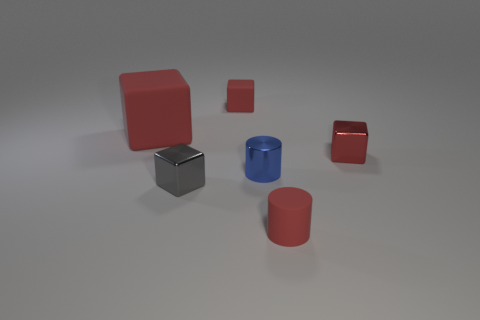How many other things are the same color as the big matte cube?
Give a very brief answer. 3. There is a metallic block behind the gray thing; does it have the same size as the blue metallic cylinder?
Ensure brevity in your answer.  Yes. Is the small gray object made of the same material as the small red object that is in front of the tiny red metal block?
Offer a very short reply. No. There is a cylinder that is in front of the blue cylinder; what is its color?
Give a very brief answer. Red. There is a metal cube to the left of the small blue metal cylinder; are there any large matte blocks to the right of it?
Provide a succinct answer. No. There is a metallic block that is behind the tiny blue shiny cylinder; is its color the same as the small rubber thing on the right side of the tiny blue cylinder?
Make the answer very short. Yes. What number of small shiny cylinders are behind the tiny red cylinder?
Give a very brief answer. 1. How many matte objects are the same color as the big cube?
Your answer should be very brief. 2. Is the small red object in front of the small gray metallic cube made of the same material as the large block?
Give a very brief answer. Yes. What number of big blocks are the same material as the small blue cylinder?
Your answer should be compact. 0. 